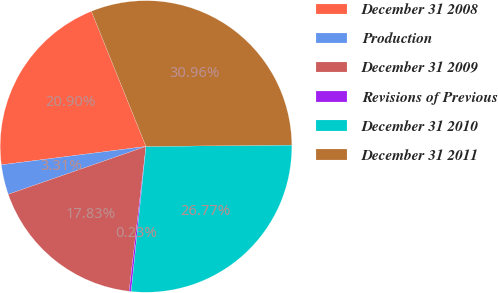Convert chart to OTSL. <chart><loc_0><loc_0><loc_500><loc_500><pie_chart><fcel>December 31 2008<fcel>Production<fcel>December 31 2009<fcel>Revisions of Previous<fcel>December 31 2010<fcel>December 31 2011<nl><fcel>20.9%<fcel>3.31%<fcel>17.83%<fcel>0.23%<fcel>26.77%<fcel>30.96%<nl></chart> 